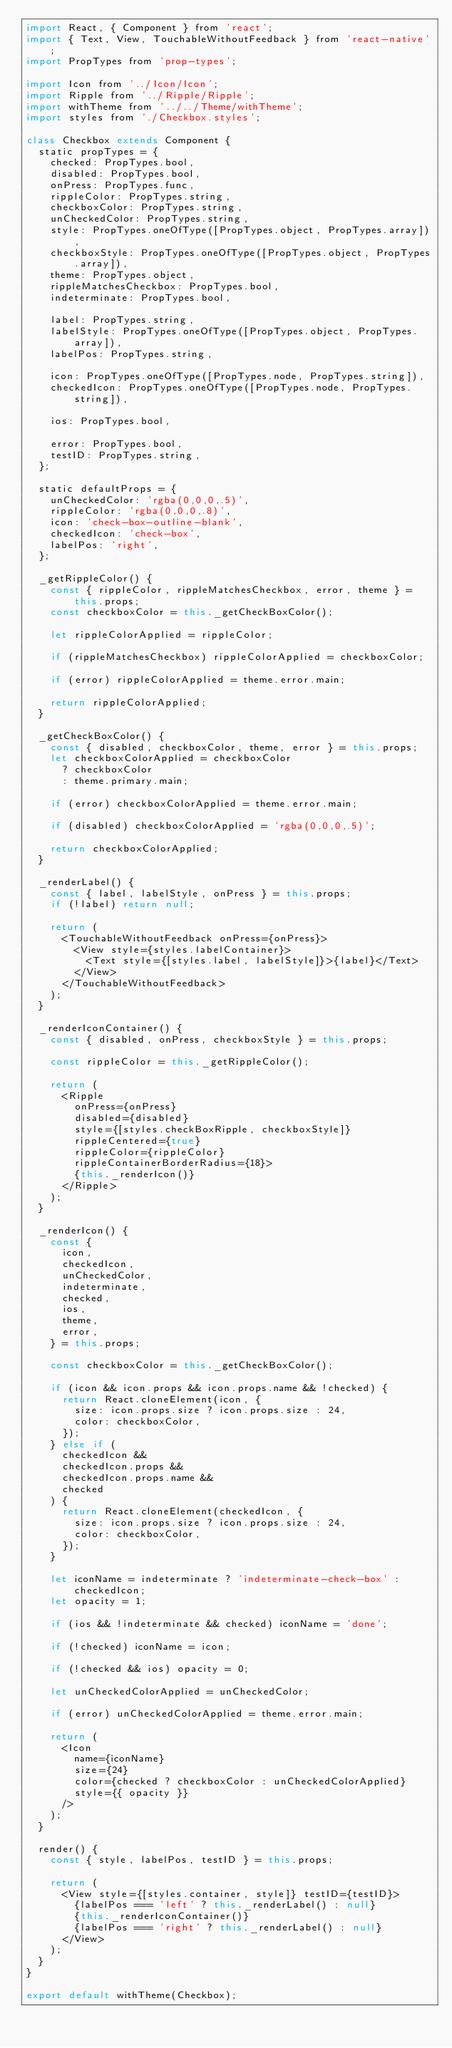<code> <loc_0><loc_0><loc_500><loc_500><_JavaScript_>import React, { Component } from 'react';
import { Text, View, TouchableWithoutFeedback } from 'react-native';
import PropTypes from 'prop-types';

import Icon from '../Icon/Icon';
import Ripple from '../Ripple/Ripple';
import withTheme from '../../Theme/withTheme';
import styles from './Checkbox.styles';

class Checkbox extends Component {
  static propTypes = {
    checked: PropTypes.bool,
    disabled: PropTypes.bool,
    onPress: PropTypes.func,
    rippleColor: PropTypes.string,
    checkboxColor: PropTypes.string,
    unCheckedColor: PropTypes.string,
    style: PropTypes.oneOfType([PropTypes.object, PropTypes.array]),
    checkboxStyle: PropTypes.oneOfType([PropTypes.object, PropTypes.array]),
    theme: PropTypes.object,
    rippleMatchesCheckbox: PropTypes.bool,
    indeterminate: PropTypes.bool,

    label: PropTypes.string,
    labelStyle: PropTypes.oneOfType([PropTypes.object, PropTypes.array]),
    labelPos: PropTypes.string,

    icon: PropTypes.oneOfType([PropTypes.node, PropTypes.string]),
    checkedIcon: PropTypes.oneOfType([PropTypes.node, PropTypes.string]),

    ios: PropTypes.bool,

    error: PropTypes.bool,
    testID: PropTypes.string,
  };

  static defaultProps = {
    unCheckedColor: 'rgba(0,0,0,.5)',
    rippleColor: 'rgba(0,0,0,.8)',
    icon: 'check-box-outline-blank',
    checkedIcon: 'check-box',
    labelPos: 'right',
  };

  _getRippleColor() {
    const { rippleColor, rippleMatchesCheckbox, error, theme } = this.props;
    const checkboxColor = this._getCheckBoxColor();

    let rippleColorApplied = rippleColor;

    if (rippleMatchesCheckbox) rippleColorApplied = checkboxColor;

    if (error) rippleColorApplied = theme.error.main;

    return rippleColorApplied;
  }

  _getCheckBoxColor() {
    const { disabled, checkboxColor, theme, error } = this.props;
    let checkboxColorApplied = checkboxColor
      ? checkboxColor
      : theme.primary.main;

    if (error) checkboxColorApplied = theme.error.main;

    if (disabled) checkboxColorApplied = 'rgba(0,0,0,.5)';

    return checkboxColorApplied;
  }

  _renderLabel() {
    const { label, labelStyle, onPress } = this.props;
    if (!label) return null;

    return (
      <TouchableWithoutFeedback onPress={onPress}>
        <View style={styles.labelContainer}>
          <Text style={[styles.label, labelStyle]}>{label}</Text>
        </View>
      </TouchableWithoutFeedback>
    );
  }

  _renderIconContainer() {
    const { disabled, onPress, checkboxStyle } = this.props;

    const rippleColor = this._getRippleColor();

    return (
      <Ripple
        onPress={onPress}
        disabled={disabled}
        style={[styles.checkBoxRipple, checkboxStyle]}
        rippleCentered={true}
        rippleColor={rippleColor}
        rippleContainerBorderRadius={18}>
        {this._renderIcon()}
      </Ripple>
    );
  }

  _renderIcon() {
    const {
      icon,
      checkedIcon,
      unCheckedColor,
      indeterminate,
      checked,
      ios,
      theme,
      error,
    } = this.props;

    const checkboxColor = this._getCheckBoxColor();

    if (icon && icon.props && icon.props.name && !checked) {
      return React.cloneElement(icon, {
        size: icon.props.size ? icon.props.size : 24,
        color: checkboxColor,
      });
    } else if (
      checkedIcon &&
      checkedIcon.props &&
      checkedIcon.props.name &&
      checked
    ) {
      return React.cloneElement(checkedIcon, {
        size: icon.props.size ? icon.props.size : 24,
        color: checkboxColor,
      });
    }

    let iconName = indeterminate ? 'indeterminate-check-box' : checkedIcon;
    let opacity = 1;

    if (ios && !indeterminate && checked) iconName = 'done';

    if (!checked) iconName = icon;

    if (!checked && ios) opacity = 0;

    let unCheckedColorApplied = unCheckedColor;

    if (error) unCheckedColorApplied = theme.error.main;

    return (
      <Icon
        name={iconName}
        size={24}
        color={checked ? checkboxColor : unCheckedColorApplied}
        style={{ opacity }}
      />
    );
  }

  render() {
    const { style, labelPos, testID } = this.props;

    return (
      <View style={[styles.container, style]} testID={testID}>
        {labelPos === 'left' ? this._renderLabel() : null}
        {this._renderIconContainer()}
        {labelPos === 'right' ? this._renderLabel() : null}
      </View>
    );
  }
}

export default withTheme(Checkbox);
</code> 